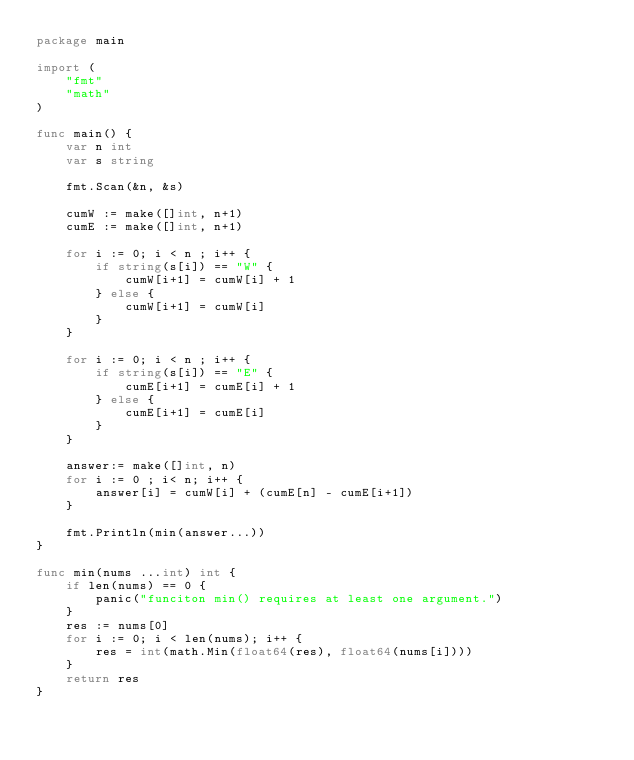<code> <loc_0><loc_0><loc_500><loc_500><_Go_>package main

import (
	"fmt"
	"math"
)

func main() {
	var n int
	var s string

	fmt.Scan(&n, &s)

	cumW := make([]int, n+1)
	cumE := make([]int, n+1)

	for i := 0; i < n ; i++ {
		if string(s[i]) == "W" {
			cumW[i+1] = cumW[i] + 1
		} else {
			cumW[i+1] = cumW[i]
		}
	}

	for i := 0; i < n ; i++ {
		if string(s[i]) == "E" {
			cumE[i+1] = cumE[i] + 1
		} else {
			cumE[i+1] = cumE[i]
		}
	}

	answer:= make([]int, n)
	for i := 0 ; i< n; i++ {
		answer[i] = cumW[i] + (cumE[n] - cumE[i+1])
	}

	fmt.Println(min(answer...))
}

func min(nums ...int) int {
	if len(nums) == 0 {
		panic("funciton min() requires at least one argument.")
	}
	res := nums[0]
	for i := 0; i < len(nums); i++ {
		res = int(math.Min(float64(res), float64(nums[i])))
	}
	return res
}
</code> 